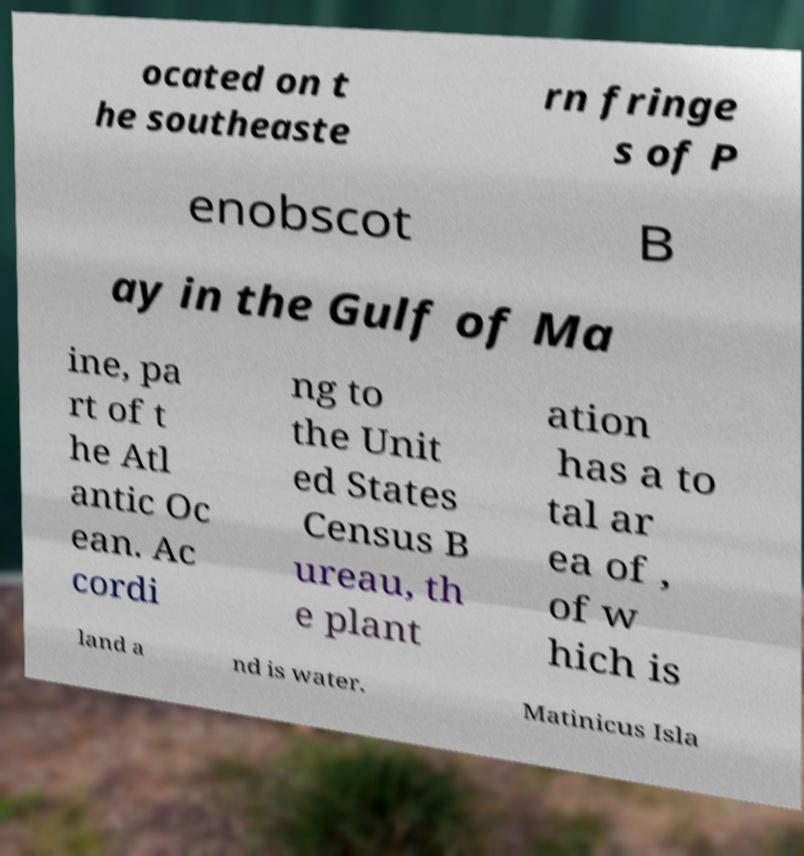What messages or text are displayed in this image? I need them in a readable, typed format. ocated on t he southeaste rn fringe s of P enobscot B ay in the Gulf of Ma ine, pa rt of t he Atl antic Oc ean. Ac cordi ng to the Unit ed States Census B ureau, th e plant ation has a to tal ar ea of , of w hich is land a nd is water. Matinicus Isla 